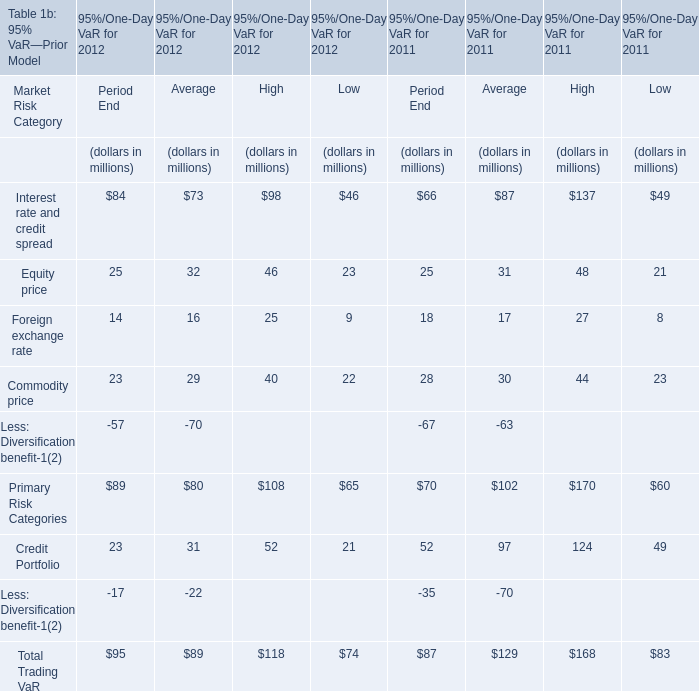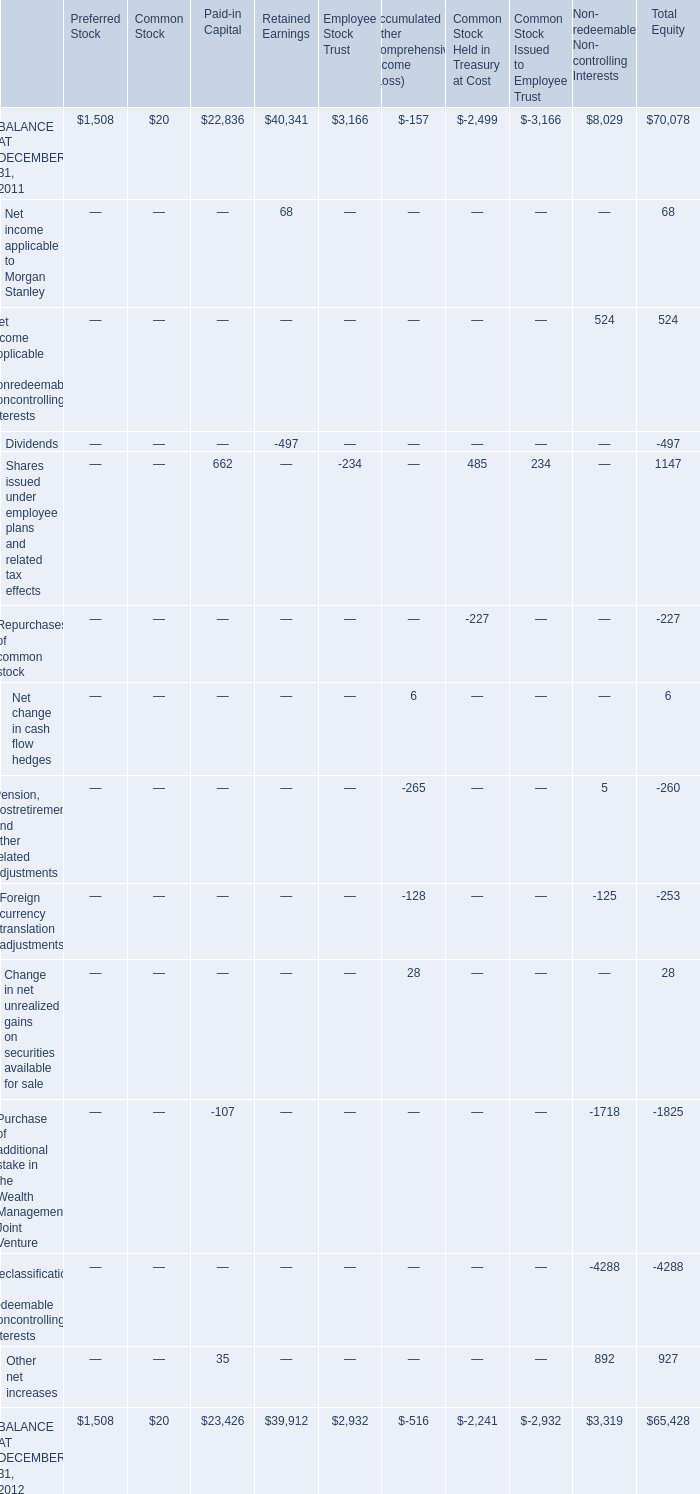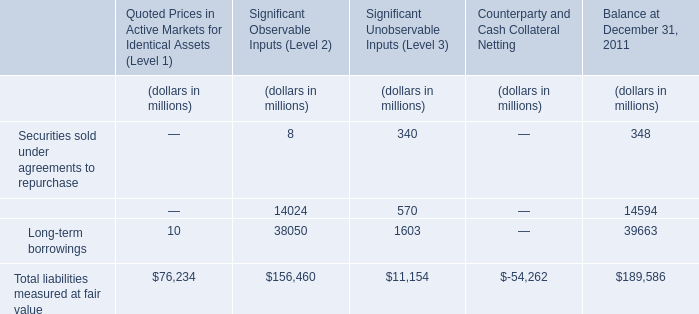What will Primary Risk Categories for Period End reach in 2013 if it continues to grow at its current rate? (in million) 
Computations: (89 * (1 + ((89 - 70) / 70)))
Answer: 113.15714. 